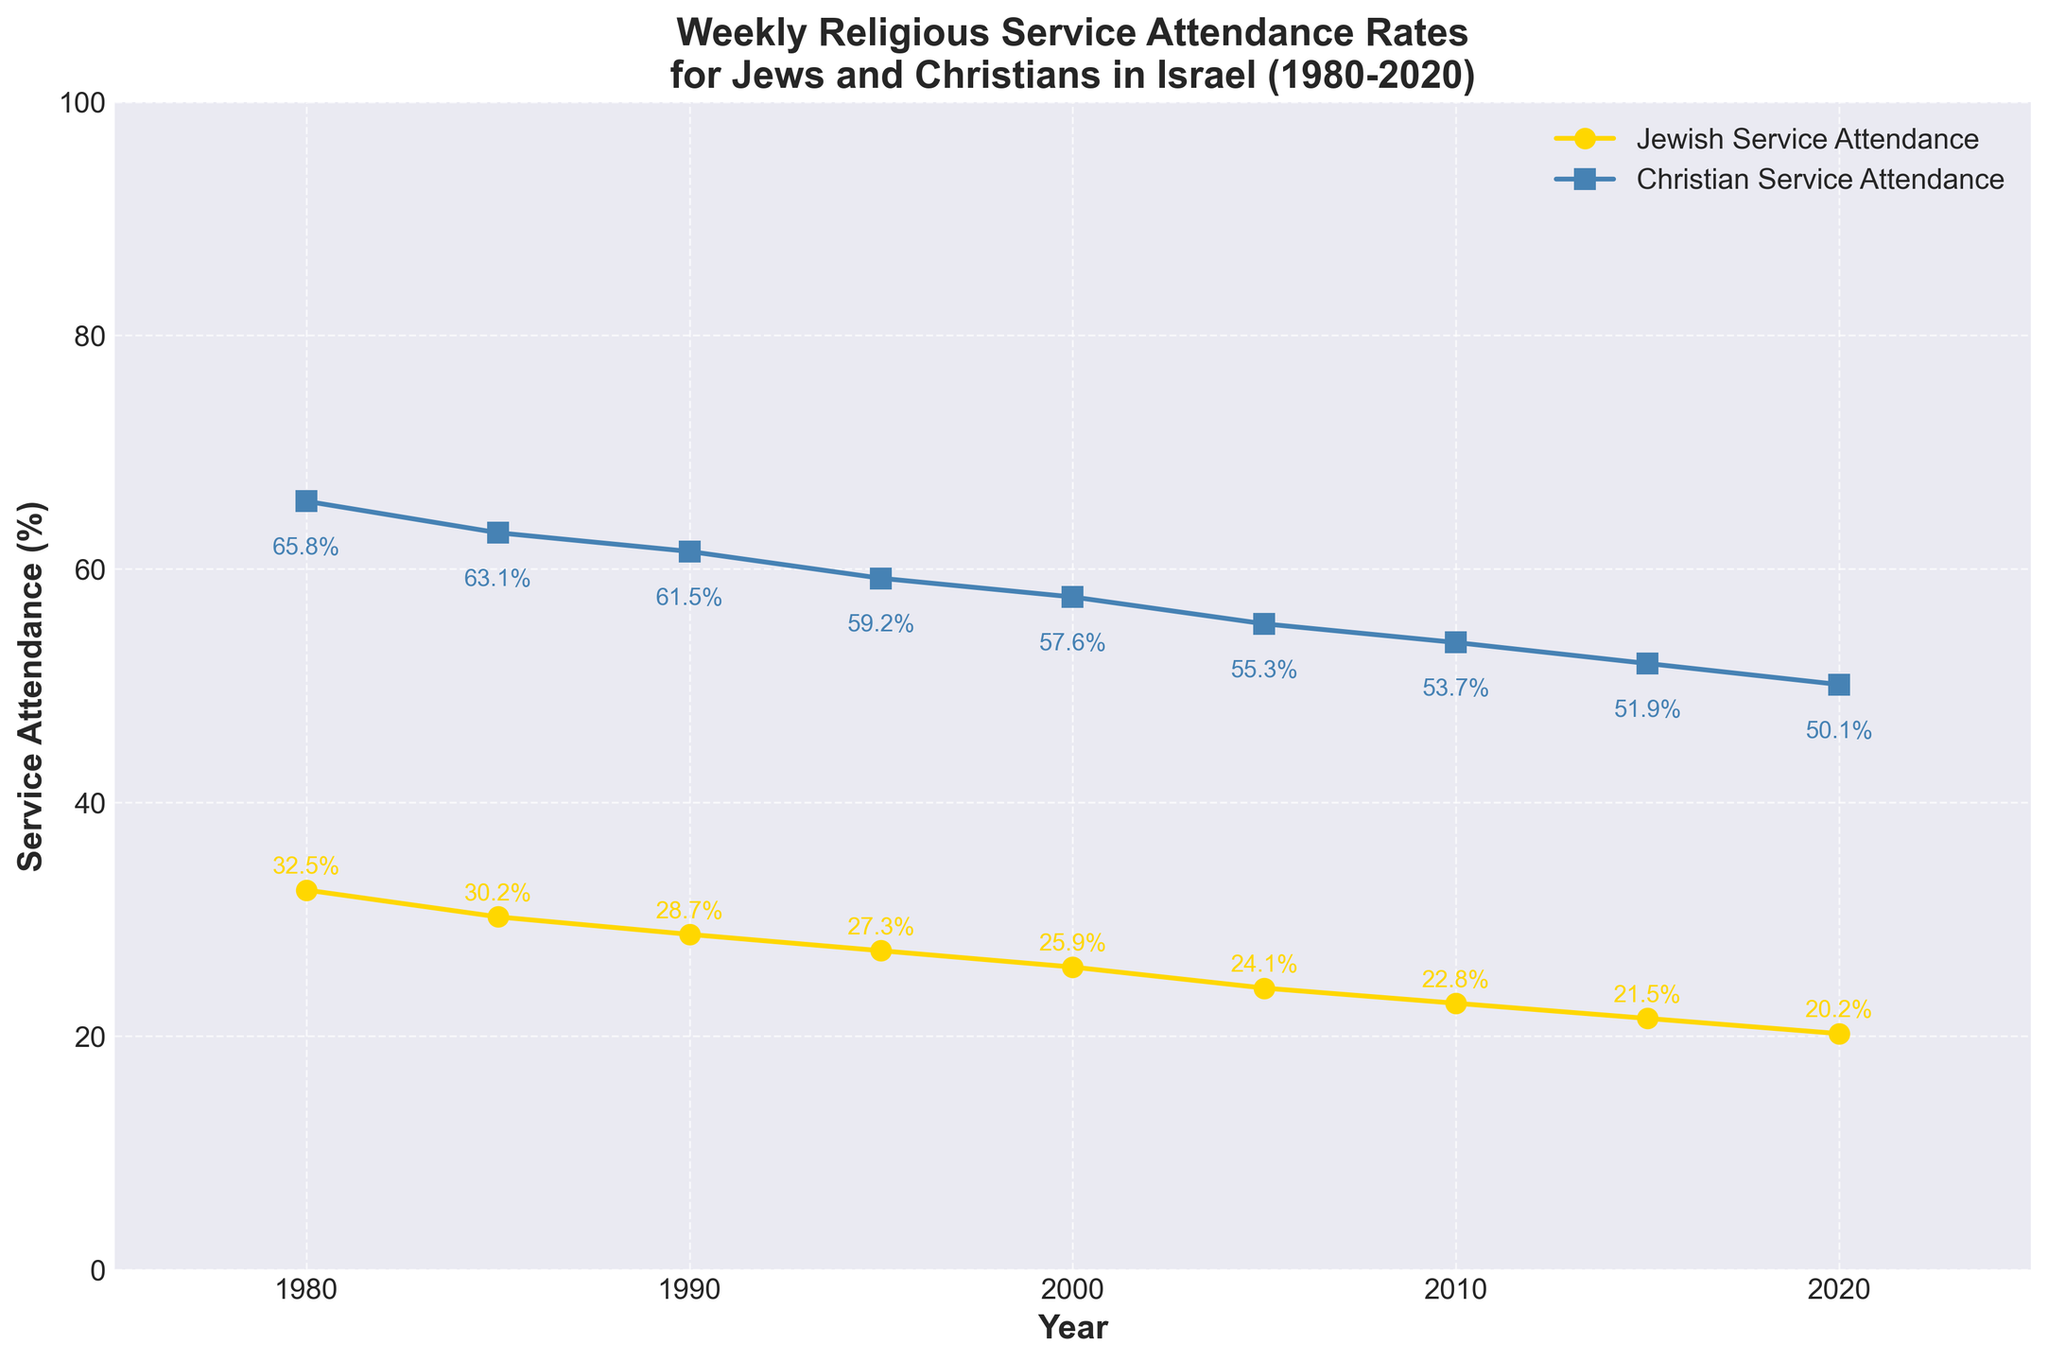What is the overall trend for Jewish service attendance between 1980 and 2020? To determine the overall trend, observe the line representing Jewish Service Attendance. Notice that it descends consistently from 32.5% in 1980 to 20.2% in 2020. This indicates a decreasing trend over the four decades.
Answer: Decreasing What is the difference in Christian service attendance rates between 1980 and 2020? To find the difference, subtract the 2020 attendance rate from the 1980 rate: 65.8% (1980) - 50.1% (2020) = 15.7%.
Answer: 15.7% Which year had the smallest difference between Jewish and Christian service attendance? Determine the difference for each year by subtracting the Jewish attendance from the Christian attendance. The smallest difference occurs in 2020 with a value of 50.1% - 20.2% = 29.9%.
Answer: 2020 By how much did the Jewish service attendance rate decrease from 1980 to 2010? Calculate the decrease by subtracting the 2010 attendance rate from the 1980 rate: 32.5% (1980) - 22.8% (2010) = 9.7%.
Answer: 9.7% Compare the trends in service attendance for Jews and Christians from 1980 to 2020. Both trends can be observed by comparing the slopes of the lines. Jewish service attendance shows a steady decline from 32.5% to 20.2%, while Christian service attendance also declines but at a slower rate from 65.8% to 50.1%. Both groups exhibit a downward trend, but the decline is steeper for Jews.
Answer: Both declining, Jews steeper What was the attendance rate for Christians in 2000? Locate the point on the Christian Service Attendance line corresponding to the year 2000. The value is approximately 57.6%.
Answer: 57.6% In what year did Jewish service attendance drop below 30%? Examine the Jewish Service Attendance line and identify the first year the rate falls below 30%. That year is 1985.
Answer: 1985 By approximately how many percentage points has Christian service attendance decreased each decade? To estimate, take the overall decrease (65.8% in 1980 to 50.1% in 2020, a total of 15.7%) and divide it by the number of decades (4): 15.7% / 4 = roughly 3.925% per decade.
Answer: 3.925% What are the attendance rates for both groups in the mid-point year between 1980 and 2020? Identify the mid-point year, which is 2000. Read off the values: Jewish attendance was 25.9% and Christian attendance was 57.6%.
Answer: Jewish: 25.9%, Christian: 57.6% How many years did it take for Jewish service attendance to drop from 30% to approximately 20%? Identify when the Jewish attendance first drops below 30% (1985) and then when it reaches approximately 20% (2020). The number of years between these points is 2020 - 1985 = 35 years.
Answer: 35 years 